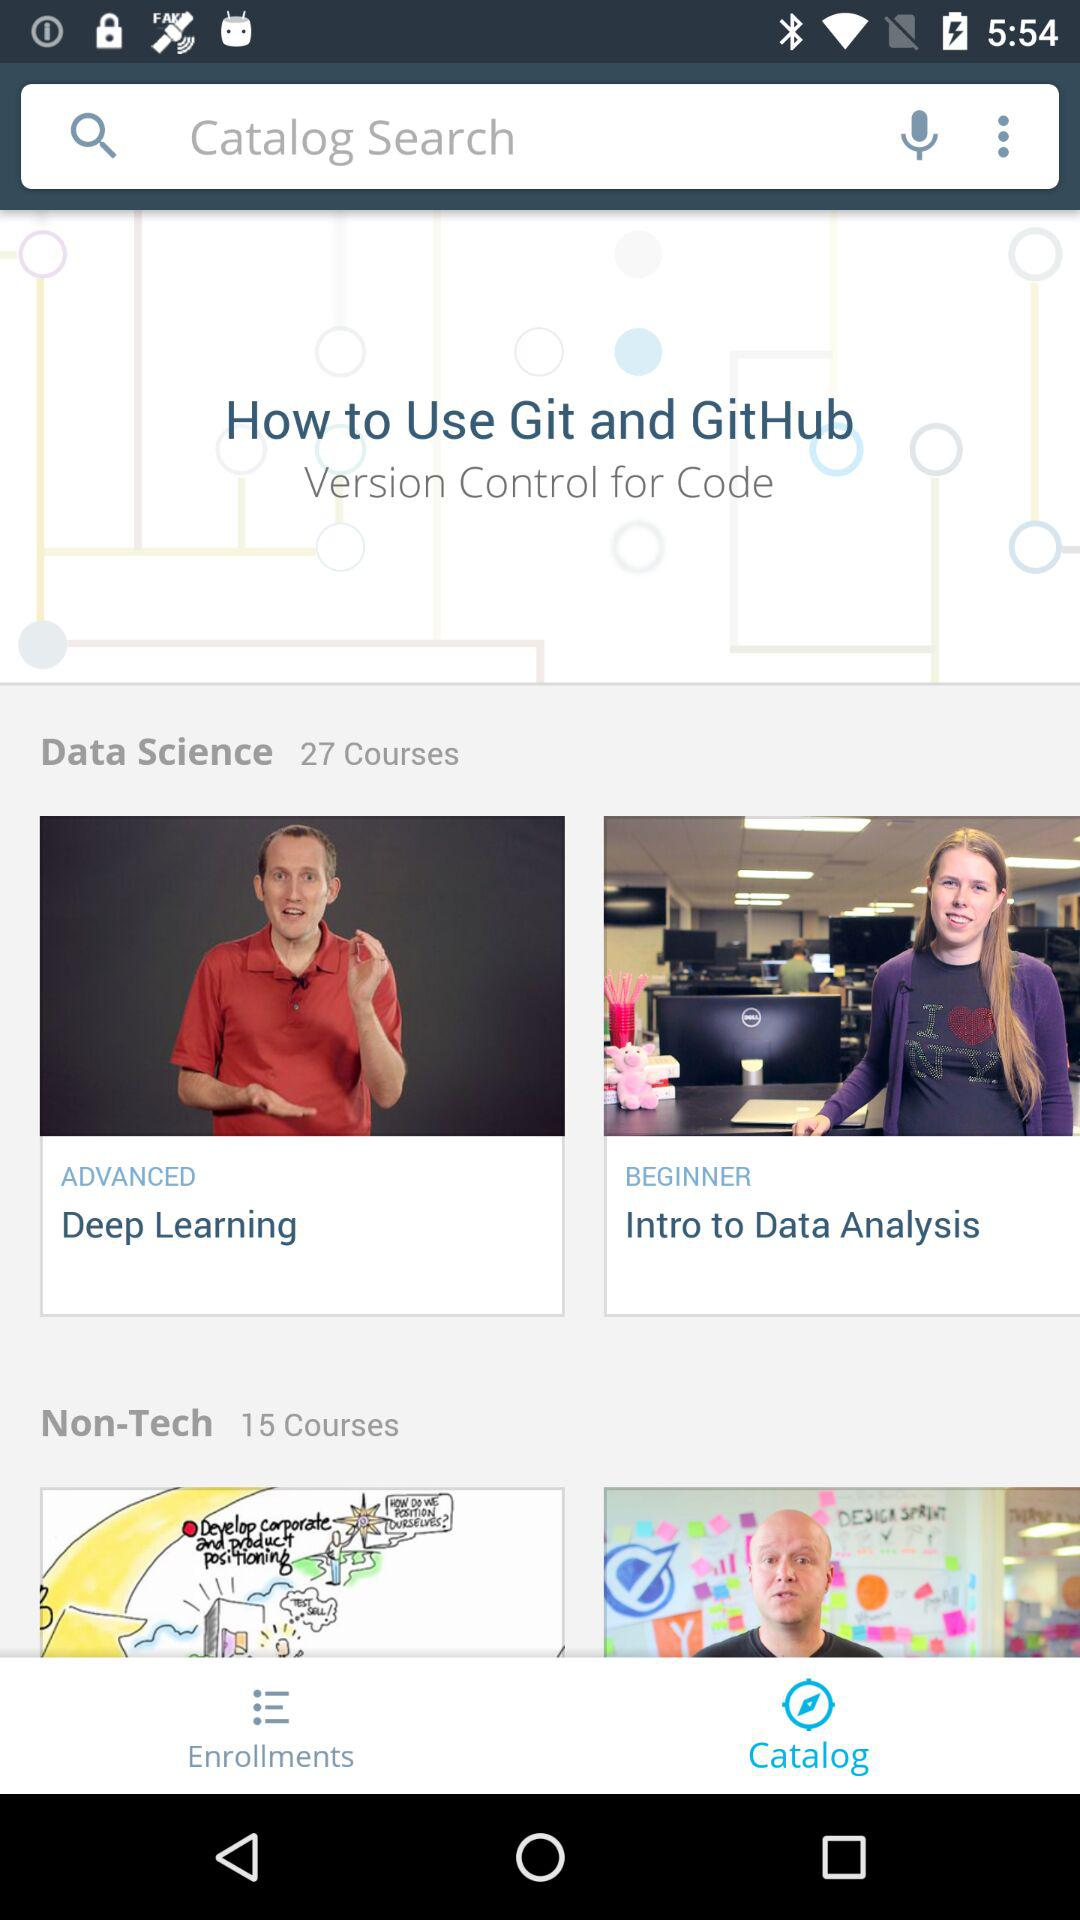How many courses are there in total?
Answer the question using a single word or phrase. 42 